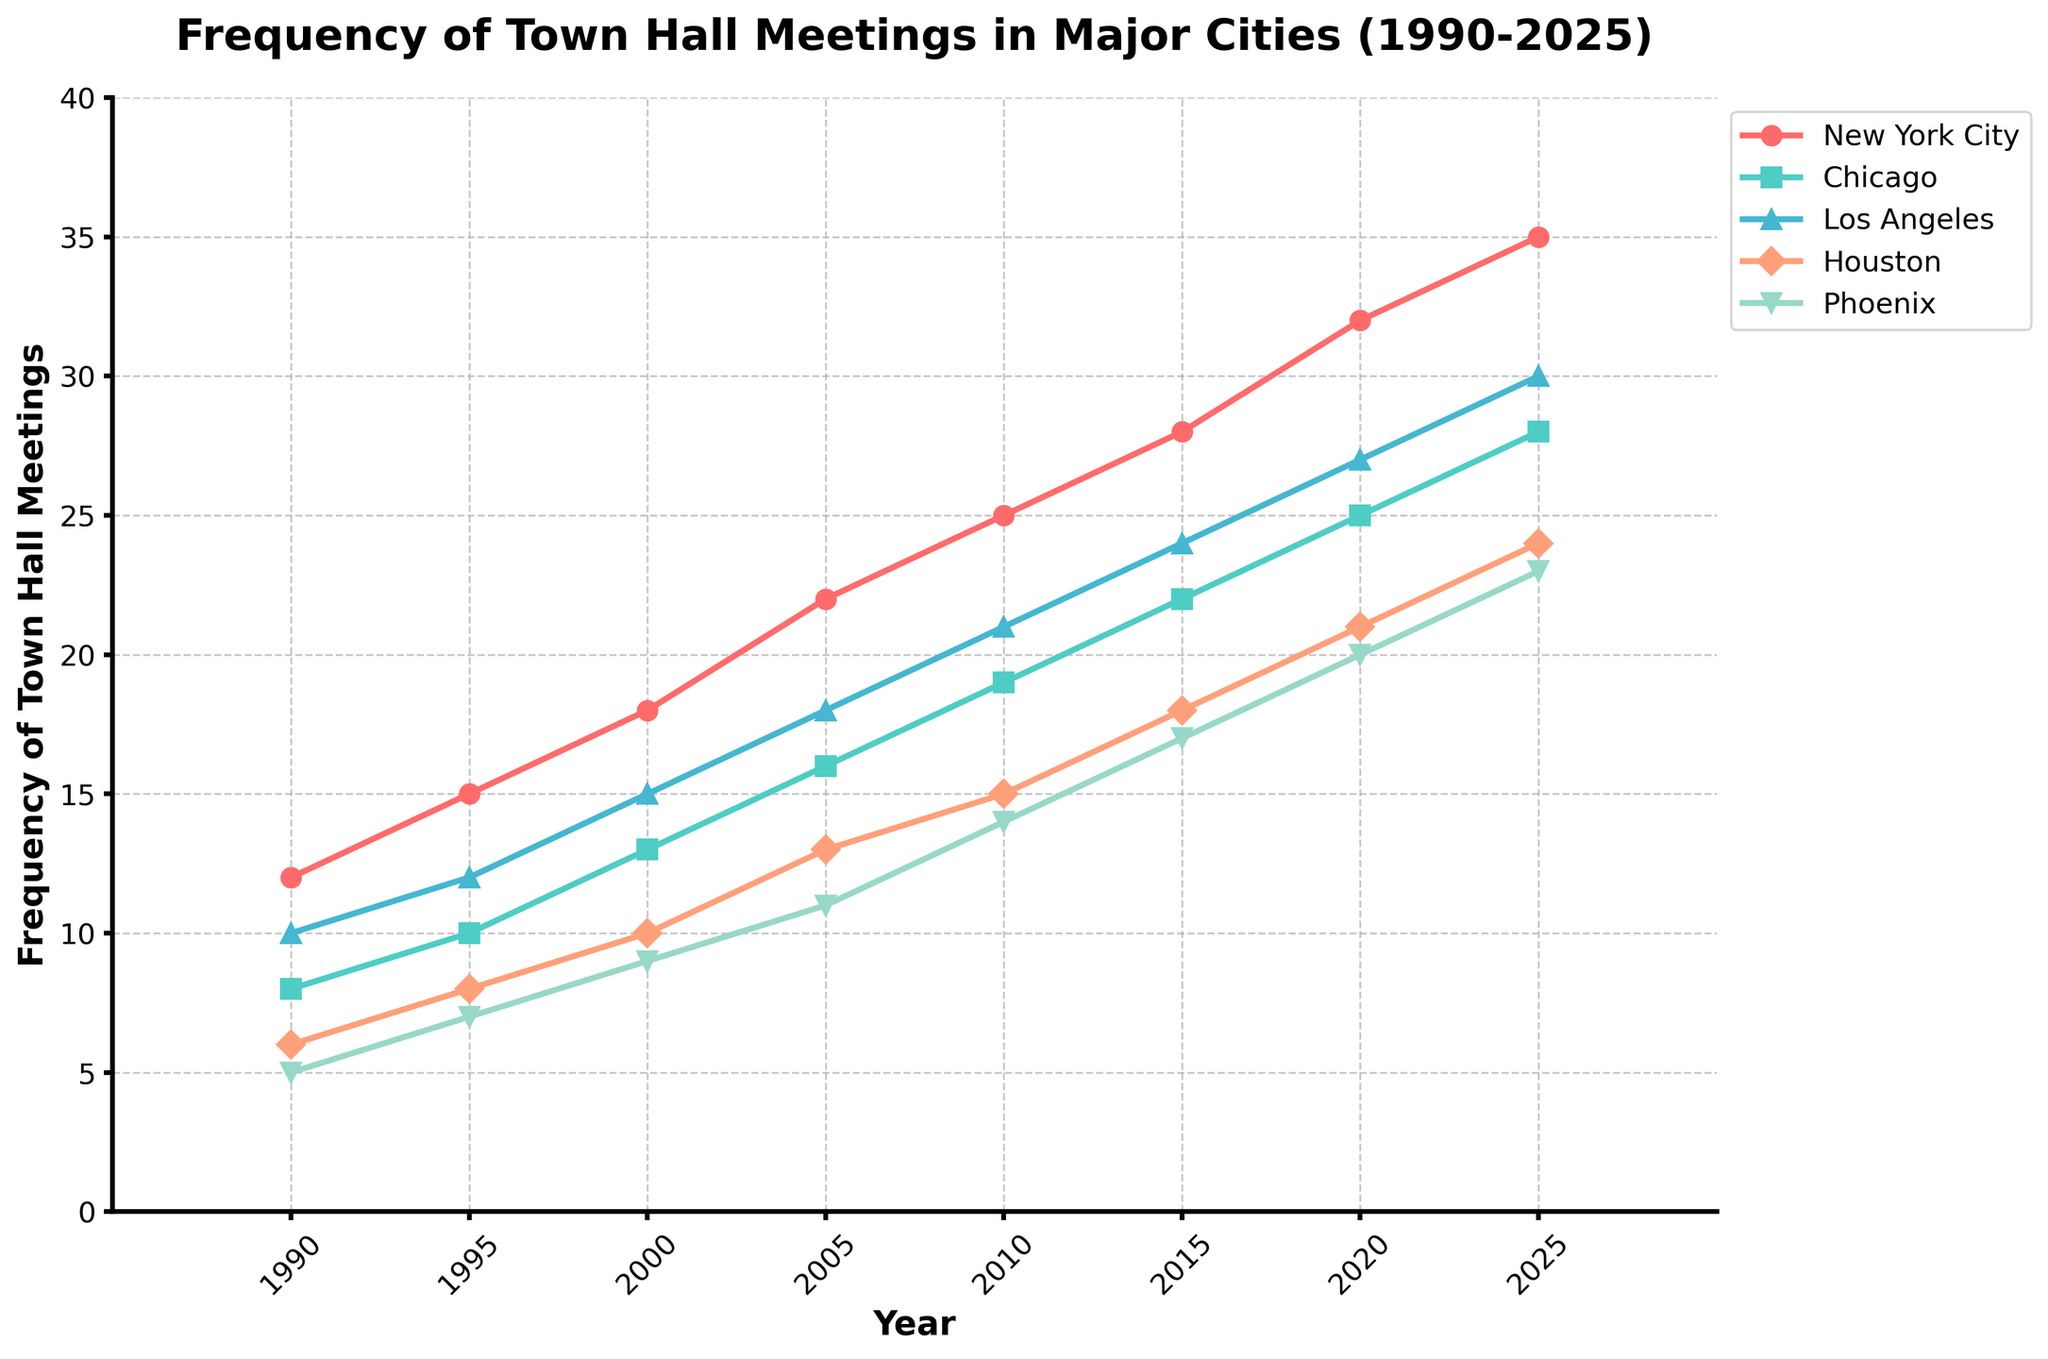What's the trend in frequency of town hall meetings for New York City from 1990 to 2025? From the visual line, New York City's trend is upward over the years. Start at 12 in 1990 and increase steadily up to 35 by 2025.
Answer: Upward Which city held the most town hall meetings in 2025? By looking at the height of the lines at the 2025 point, New York City's line is the highest, indicating it held the most meetings.
Answer: New York City How many more meetings did Los Angeles hold in 2020 compared to Houston? Referring to the lines, Los Angeles held 27 meetings, while Houston held 21 in 2020. Hence, 27 - 21 = 6.
Answer: 6 What year did Phoenix first surpass 10 town hall meetings? From the Phoenix line, it surpassed 10 meetings between 2000 and 2005, hitting exactly 11 in 2005.
Answer: 2005 Which two cities have the closest number of town hall meetings in 1995? By comparing the markers for 1995, Chicago with 10 meetings and Los Angeles with 12 are the closest.
Answer: Chicago and Los Angeles What is the average frequency of town hall meetings in Chicago over the shown years? Chicago's meetings counts are [8, 10, 13, 16, 19, 22, 25, 28]. Sum = 141, and there are 8 years. Average = 141 / 8 = 17.625.
Answer: 17.625 Which city has the steepest increase in the frequency of town hall meetings between 1990 and 2025? Comparing the slopes visually, New York City's line appears to have the steepest climb.
Answer: New York City In which period did Houston see the biggest increase in town hall meetings? From visual inspection, Houston saw the biggest increase between 2000 and 2005 (10-13).
Answer: 2000-2005 How does the trend in Phoenix compare to the trend in New York City? Both trends are upward, but New York City's increase is more rapid and higher overall compared to Phoenix.
Answer: Both upward, NYC more rapid Add up all the town hall meetings held in 2020 across the five cities. What is the total? Summing the meeting counts for 2020, NYC (32), Chicago (25), LA (27), Houston (21), Phoenix (20). Total = 32 + 25 + 27 + 21 + 20 = 125.
Answer: 125 